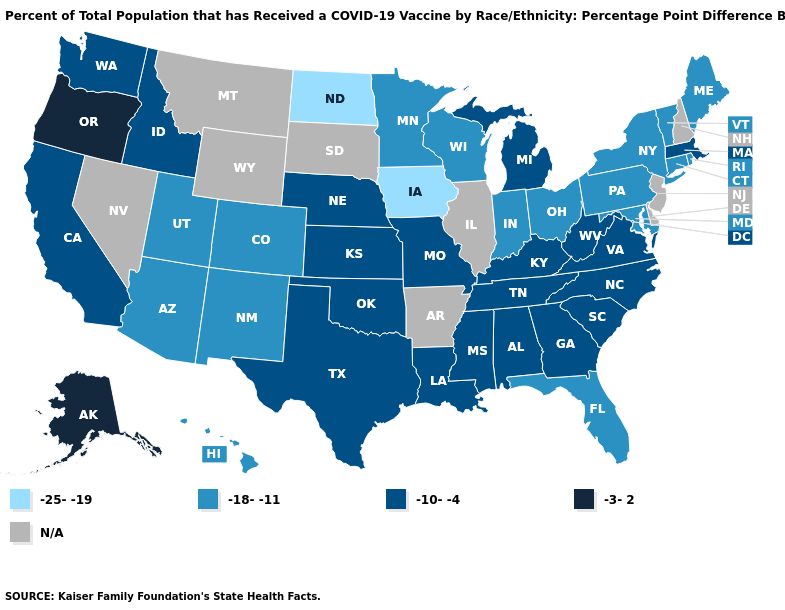Name the states that have a value in the range -10--4?
Give a very brief answer. Alabama, California, Georgia, Idaho, Kansas, Kentucky, Louisiana, Massachusetts, Michigan, Mississippi, Missouri, Nebraska, North Carolina, Oklahoma, South Carolina, Tennessee, Texas, Virginia, Washington, West Virginia. Among the states that border Michigan , which have the highest value?
Be succinct. Indiana, Ohio, Wisconsin. What is the value of Missouri?
Be succinct. -10--4. What is the value of Tennessee?
Give a very brief answer. -10--4. Among the states that border Kansas , does Missouri have the highest value?
Quick response, please. Yes. Does Alaska have the highest value in the USA?
Be succinct. Yes. Which states have the lowest value in the USA?
Write a very short answer. Iowa, North Dakota. Which states have the lowest value in the Northeast?
Quick response, please. Connecticut, Maine, New York, Pennsylvania, Rhode Island, Vermont. Name the states that have a value in the range -3-2?
Keep it brief. Alaska, Oregon. Is the legend a continuous bar?
Keep it brief. No. Which states have the highest value in the USA?
Write a very short answer. Alaska, Oregon. What is the value of Kentucky?
Short answer required. -10--4. Among the states that border Kentucky , which have the lowest value?
Give a very brief answer. Indiana, Ohio. What is the value of Virginia?
Write a very short answer. -10--4. 